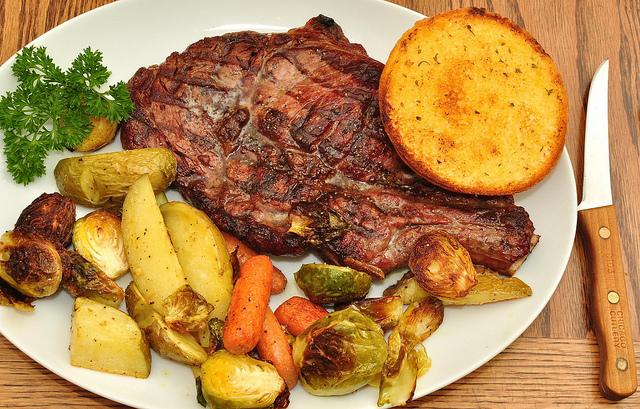What type of silverware is on the side?
Concise answer only. Knife. Was this food fried, grilled, or stewed?
Give a very brief answer. Grilled. Is the food tasty?
Answer briefly. Yes. 